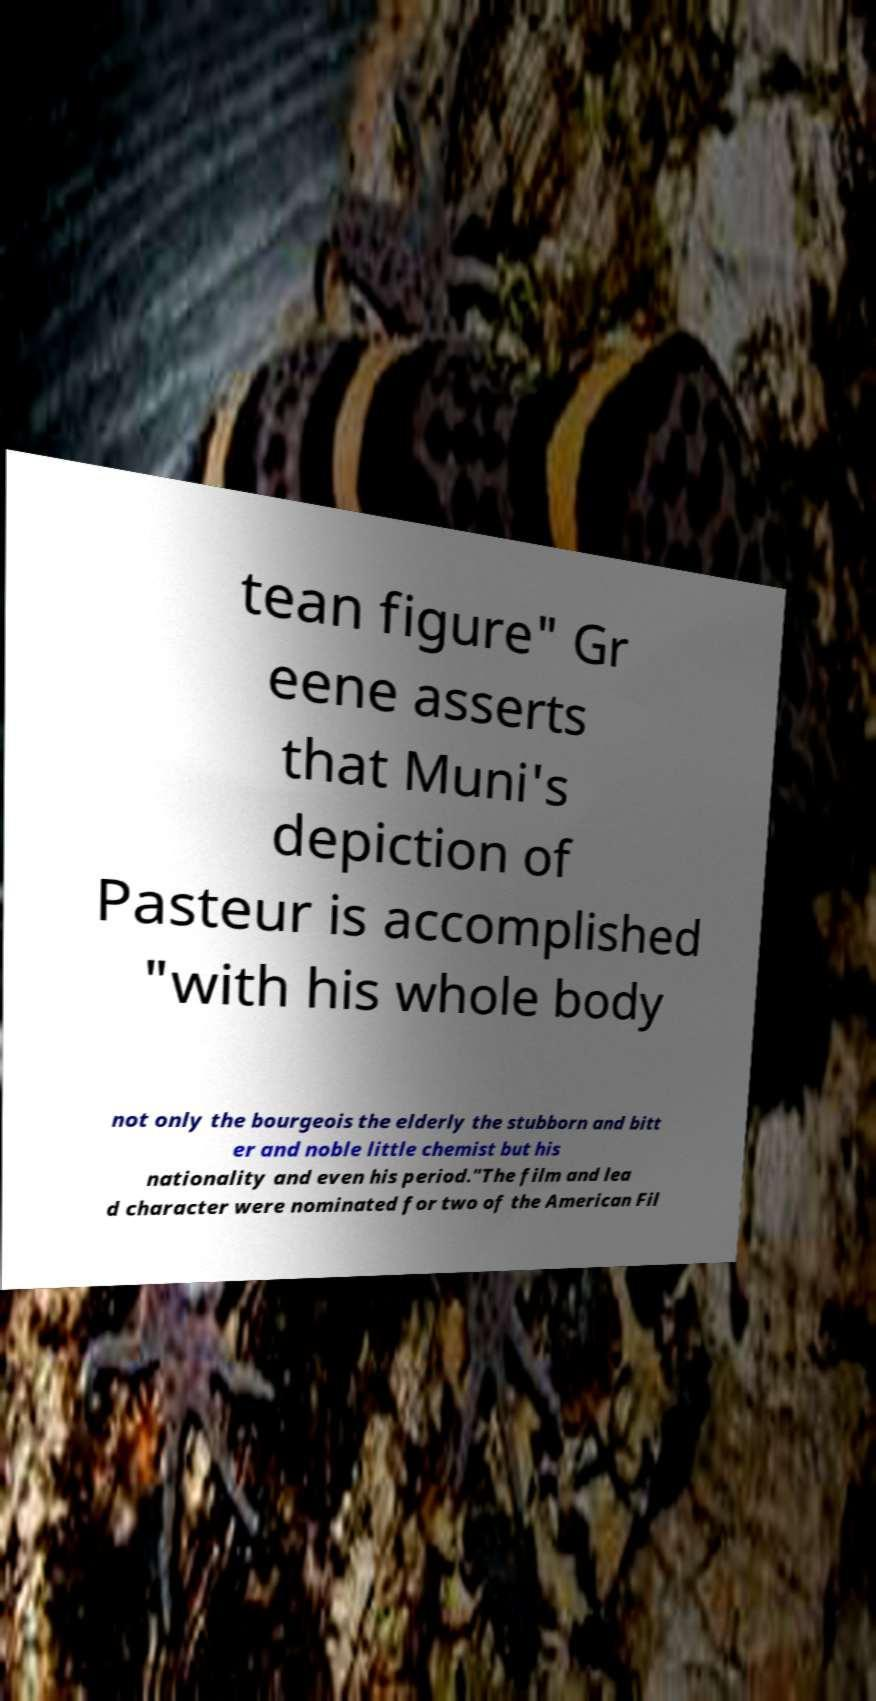Please identify and transcribe the text found in this image. tean figure" Gr eene asserts that Muni's depiction of Pasteur is accomplished "with his whole body not only the bourgeois the elderly the stubborn and bitt er and noble little chemist but his nationality and even his period."The film and lea d character were nominated for two of the American Fil 